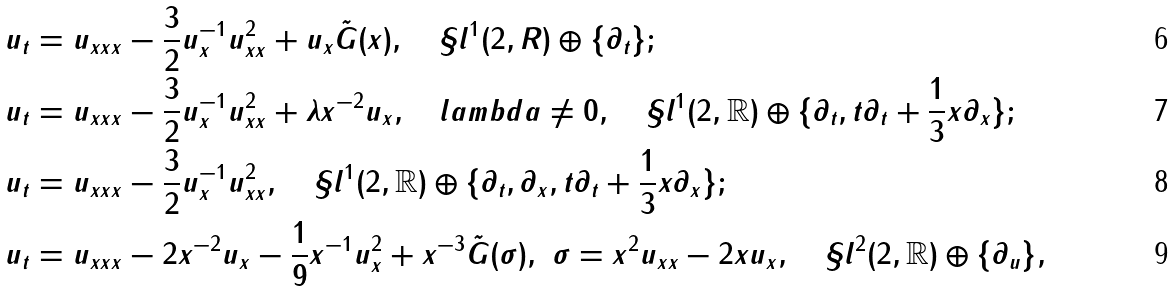<formula> <loc_0><loc_0><loc_500><loc_500>& u _ { t } = u _ { x x x } - \frac { 3 } { 2 } u ^ { - 1 } _ { x } u ^ { 2 } _ { x x } + u _ { x } { \tilde { G } } ( x ) , \quad \S l ^ { 1 } ( 2 , R ) \oplus \{ \partial _ { t } \} ; \\ & u _ { t } = u _ { x x x } - \frac { 3 } { 2 } u ^ { - 1 } _ { x } u ^ { 2 } _ { x x } + \lambda x ^ { - 2 } u _ { x } , \quad l a m b d a \not = 0 , \quad \S l ^ { 1 } ( 2 , \mathbb { R } ) \oplus \{ \partial _ { t } , t \partial _ { t } + \frac { 1 } { 3 } x \partial _ { x } \} ; \\ & u _ { t } = u _ { x x x } - \frac { 3 } { 2 } u ^ { - 1 } _ { x } u ^ { 2 } _ { x x } , \quad \S l ^ { 1 } ( 2 , \mathbb { R } ) \oplus \{ \partial _ { t } , \partial _ { x } , t \partial _ { t } + \frac { 1 } { 3 } x \partial _ { x } \} ; \\ & u _ { t } = u _ { x x x } - 2 x ^ { - 2 } u _ { x } - \frac { 1 } { 9 } x ^ { - 1 } u ^ { 2 } _ { x } + x ^ { - 3 } { \tilde { G } } ( { \sigma } ) , \ { \sigma } = x ^ { 2 } u _ { x x } - 2 x u _ { x } , \quad \S l ^ { 2 } ( 2 , \mathbb { R } ) \oplus \{ \partial _ { u } \} ,</formula> 